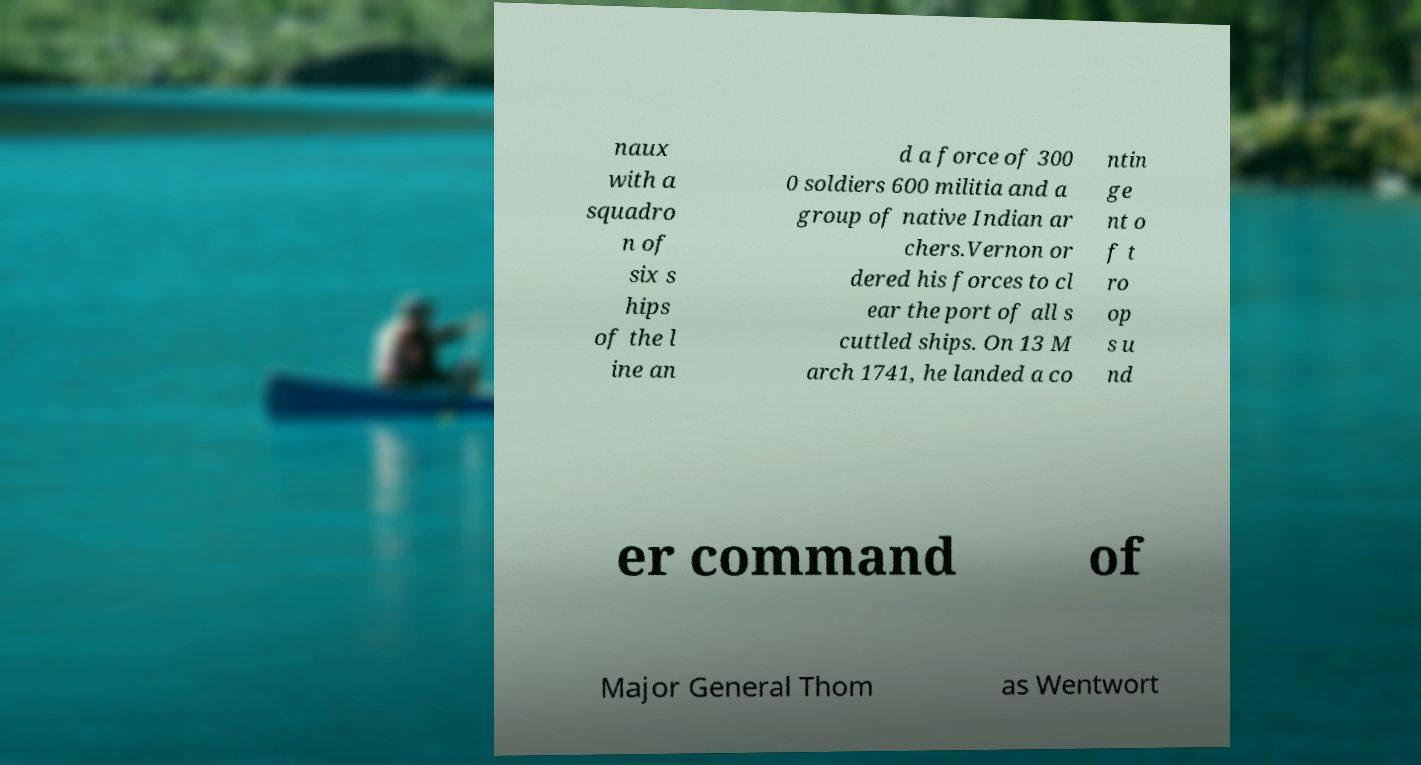Could you extract and type out the text from this image? naux with a squadro n of six s hips of the l ine an d a force of 300 0 soldiers 600 militia and a group of native Indian ar chers.Vernon or dered his forces to cl ear the port of all s cuttled ships. On 13 M arch 1741, he landed a co ntin ge nt o f t ro op s u nd er command of Major General Thom as Wentwort 